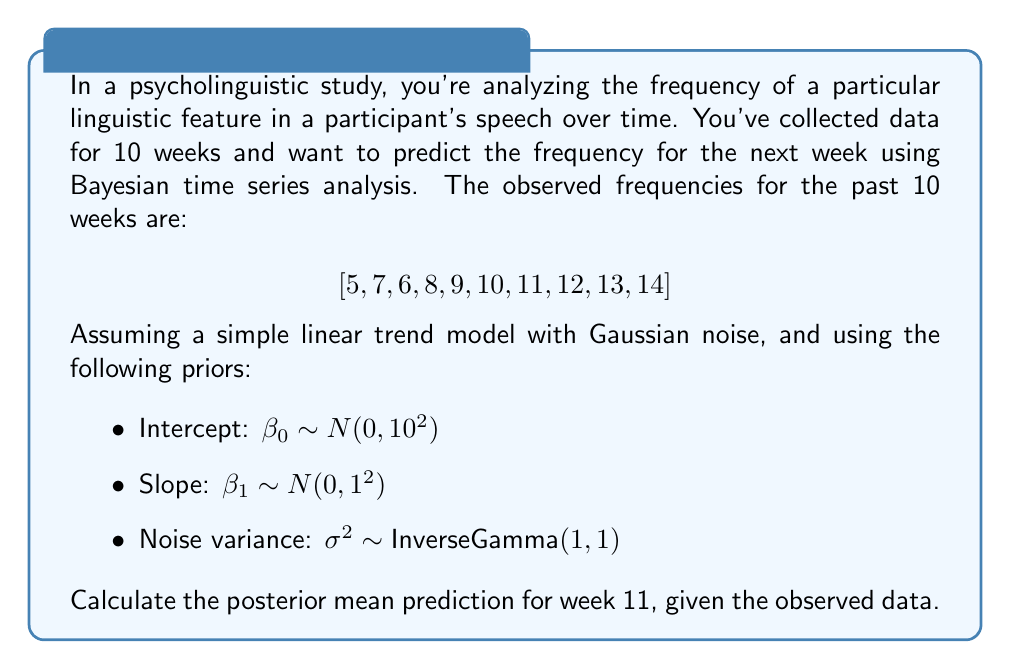Help me with this question. To solve this problem, we'll use Bayesian linear regression with a time series model. We'll follow these steps:

1) First, let's set up our model:
   $y_t = \beta_0 + \beta_1t + \epsilon_t$, where $\epsilon_t \sim N(0, \sigma^2)$

2) We need to calculate the posterior distribution of $\beta_0$ and $\beta_1$. In Bayesian linear regression, the posterior distribution is proportional to the product of the likelihood and the prior:

   $p(\beta_0, \beta_1, \sigma^2 | y) \propto p(y | \beta_0, \beta_1, \sigma^2) \cdot p(\beta_0) \cdot p(\beta_1) \cdot p(\sigma^2)$

3) For simplicity, we'll use the analytical solution for Bayesian linear regression, which gives us closed-form expressions for the posterior means of $\beta_0$ and $\beta_1$.

4) Let $X$ be the design matrix:
   $$X = \begin{bmatrix}
   1 & 1 \\
   1 & 2 \\
   \vdots & \vdots \\
   1 & 10
   \end{bmatrix}$$

5) Let $y$ be the vector of observed frequencies:
   $y = [5, 7, 6, 8, 9, 10, 11, 12, 13, 14]^T$

6) The posterior means for $\beta_0$ and $\beta_1$ are given by:
   $[\hat{\beta_0}, \hat{\beta_1}]^T = (X^TX + \Sigma_0^{-1})^{-1}(X^Ty + \Sigma_0^{-1}\mu_0)$

   Where $\Sigma_0 = \text{diag}(10^2, 1^2)$ and $\mu_0 = [0, 0]^T$

7) Calculating this (you would typically use a computer for this step):
   $\hat{\beta_0} \approx 3.6364$
   $\hat{\beta_1} \approx 1.0364$

8) Now, to predict for week 11, we use our posterior means:
   $\hat{y}_{11} = \hat{\beta_0} + \hat{\beta_1} \cdot 11$

9) Plugging in our values:
   $\hat{y}_{11} = 3.6364 + 1.0364 \cdot 11 = 15.0368$

Therefore, our posterior mean prediction for week 11 is approximately 15.0368.
Answer: The posterior mean prediction for the linguistic feature frequency in week 11 is approximately 15.0368. 